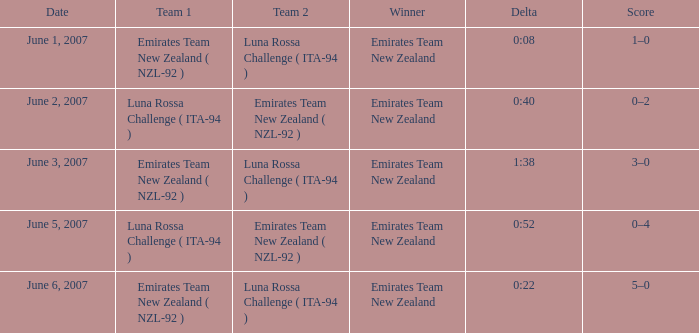Who claimed victory on june 2, 2007? Emirates Team New Zealand. 